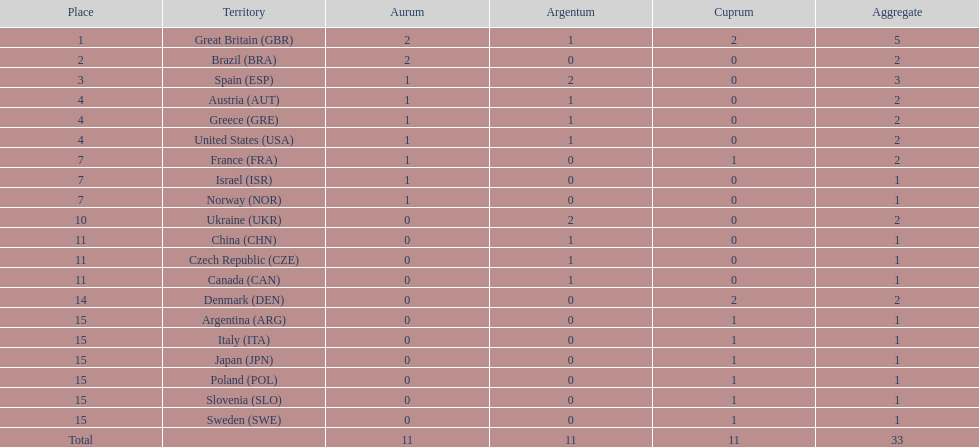Which nation was the only one to receive 3 medals? Spain (ESP). 